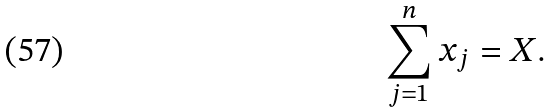Convert formula to latex. <formula><loc_0><loc_0><loc_500><loc_500>\sum _ { j = 1 } ^ { n } x _ { j } = X .</formula> 